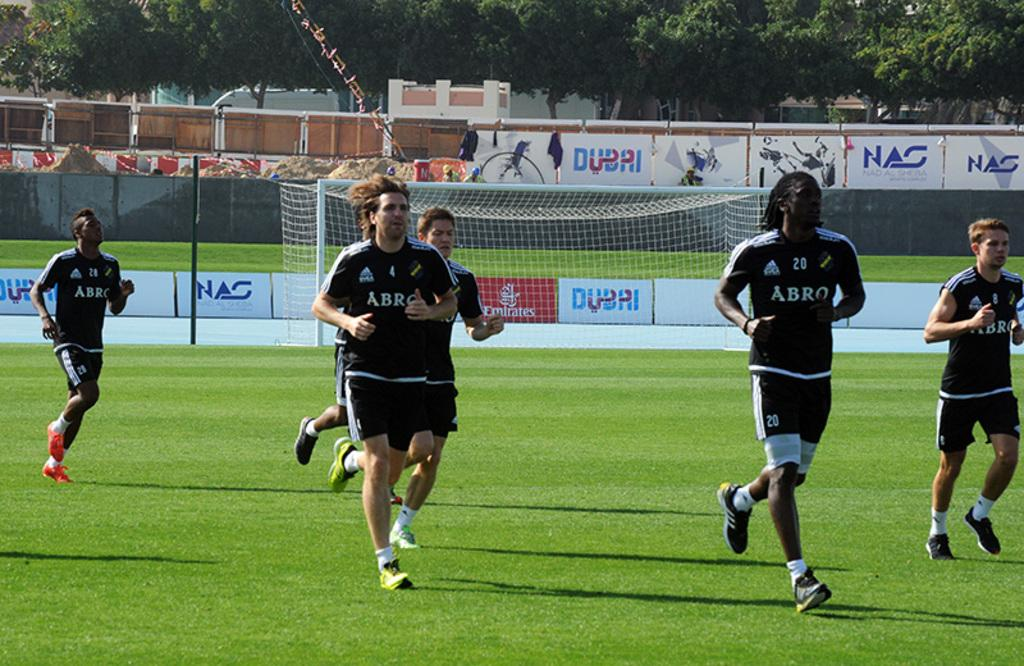<image>
Present a compact description of the photo's key features. Several soccer players jog across the field, wearing jerseys that say Arbo. 